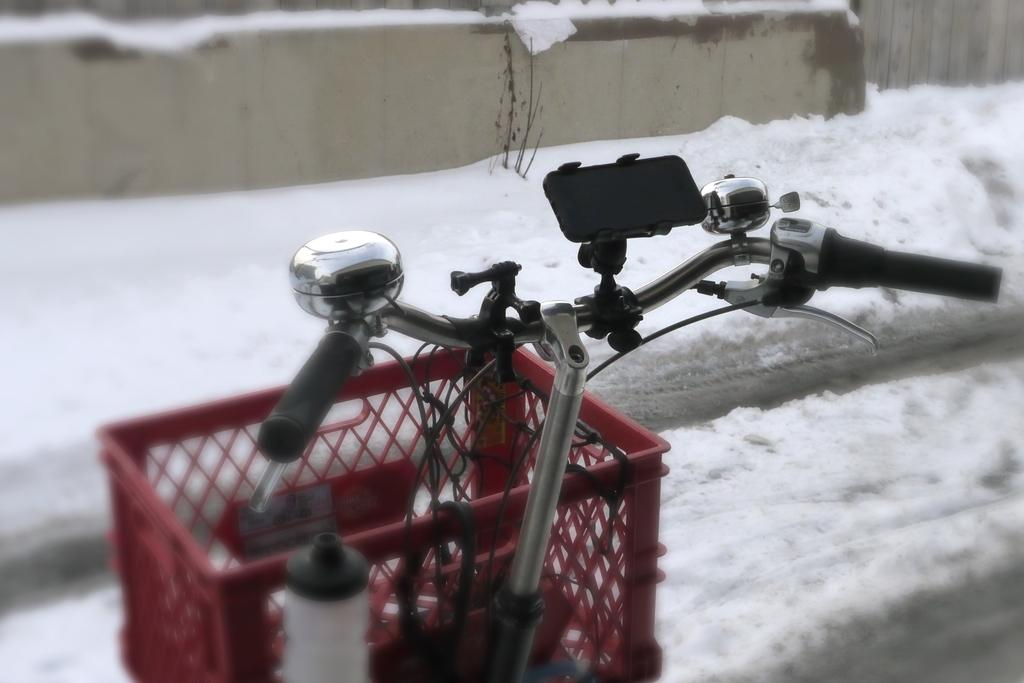What is the main object in the image? There is a bicycle in the image. What additional features does the bicycle have? The bicycle has a basket, a water bottle, and a mobile holder on the handlebars. What can be seen on the ground in the image? Snow is visible on the ground in the image. How many sponges are on the bicycle in the image? There are no sponges present on the bicycle in the image. 